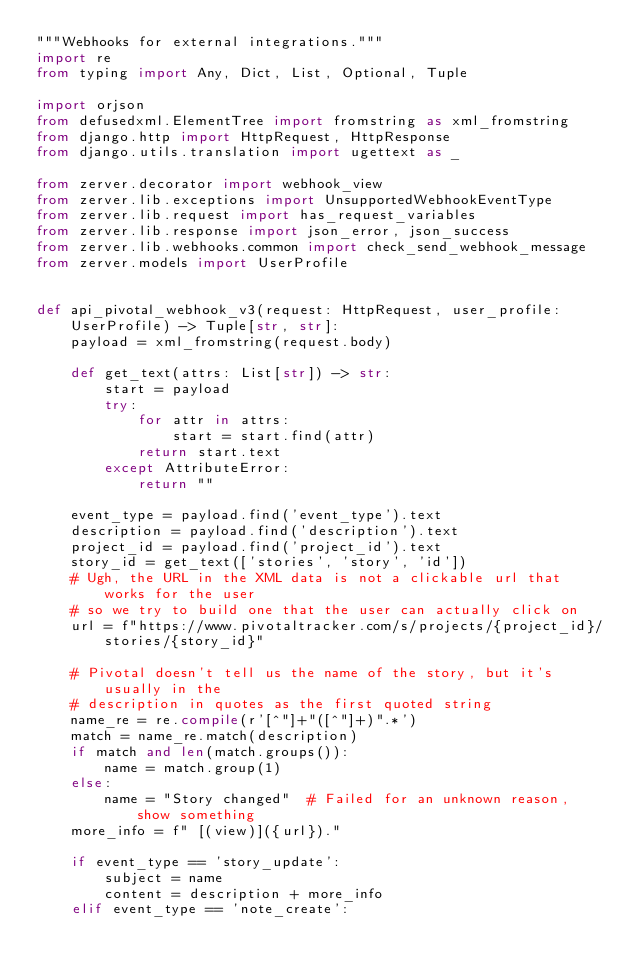<code> <loc_0><loc_0><loc_500><loc_500><_Python_>"""Webhooks for external integrations."""
import re
from typing import Any, Dict, List, Optional, Tuple

import orjson
from defusedxml.ElementTree import fromstring as xml_fromstring
from django.http import HttpRequest, HttpResponse
from django.utils.translation import ugettext as _

from zerver.decorator import webhook_view
from zerver.lib.exceptions import UnsupportedWebhookEventType
from zerver.lib.request import has_request_variables
from zerver.lib.response import json_error, json_success
from zerver.lib.webhooks.common import check_send_webhook_message
from zerver.models import UserProfile


def api_pivotal_webhook_v3(request: HttpRequest, user_profile: UserProfile) -> Tuple[str, str]:
    payload = xml_fromstring(request.body)

    def get_text(attrs: List[str]) -> str:
        start = payload
        try:
            for attr in attrs:
                start = start.find(attr)
            return start.text
        except AttributeError:
            return ""

    event_type = payload.find('event_type').text
    description = payload.find('description').text
    project_id = payload.find('project_id').text
    story_id = get_text(['stories', 'story', 'id'])
    # Ugh, the URL in the XML data is not a clickable url that works for the user
    # so we try to build one that the user can actually click on
    url = f"https://www.pivotaltracker.com/s/projects/{project_id}/stories/{story_id}"

    # Pivotal doesn't tell us the name of the story, but it's usually in the
    # description in quotes as the first quoted string
    name_re = re.compile(r'[^"]+"([^"]+)".*')
    match = name_re.match(description)
    if match and len(match.groups()):
        name = match.group(1)
    else:
        name = "Story changed"  # Failed for an unknown reason, show something
    more_info = f" [(view)]({url})."

    if event_type == 'story_update':
        subject = name
        content = description + more_info
    elif event_type == 'note_create':</code> 